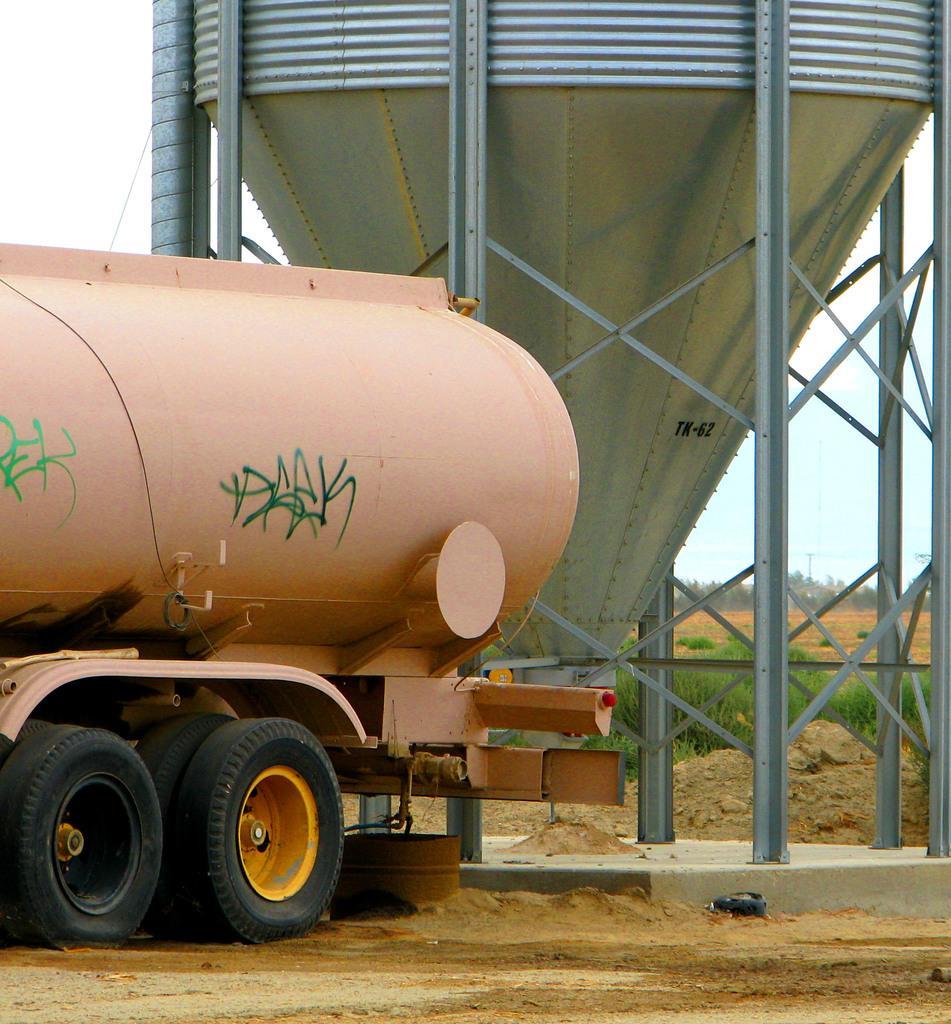Please provide a concise description of this image. Here we can see a vehicle with tanker, container and plants. Far there are trees. 